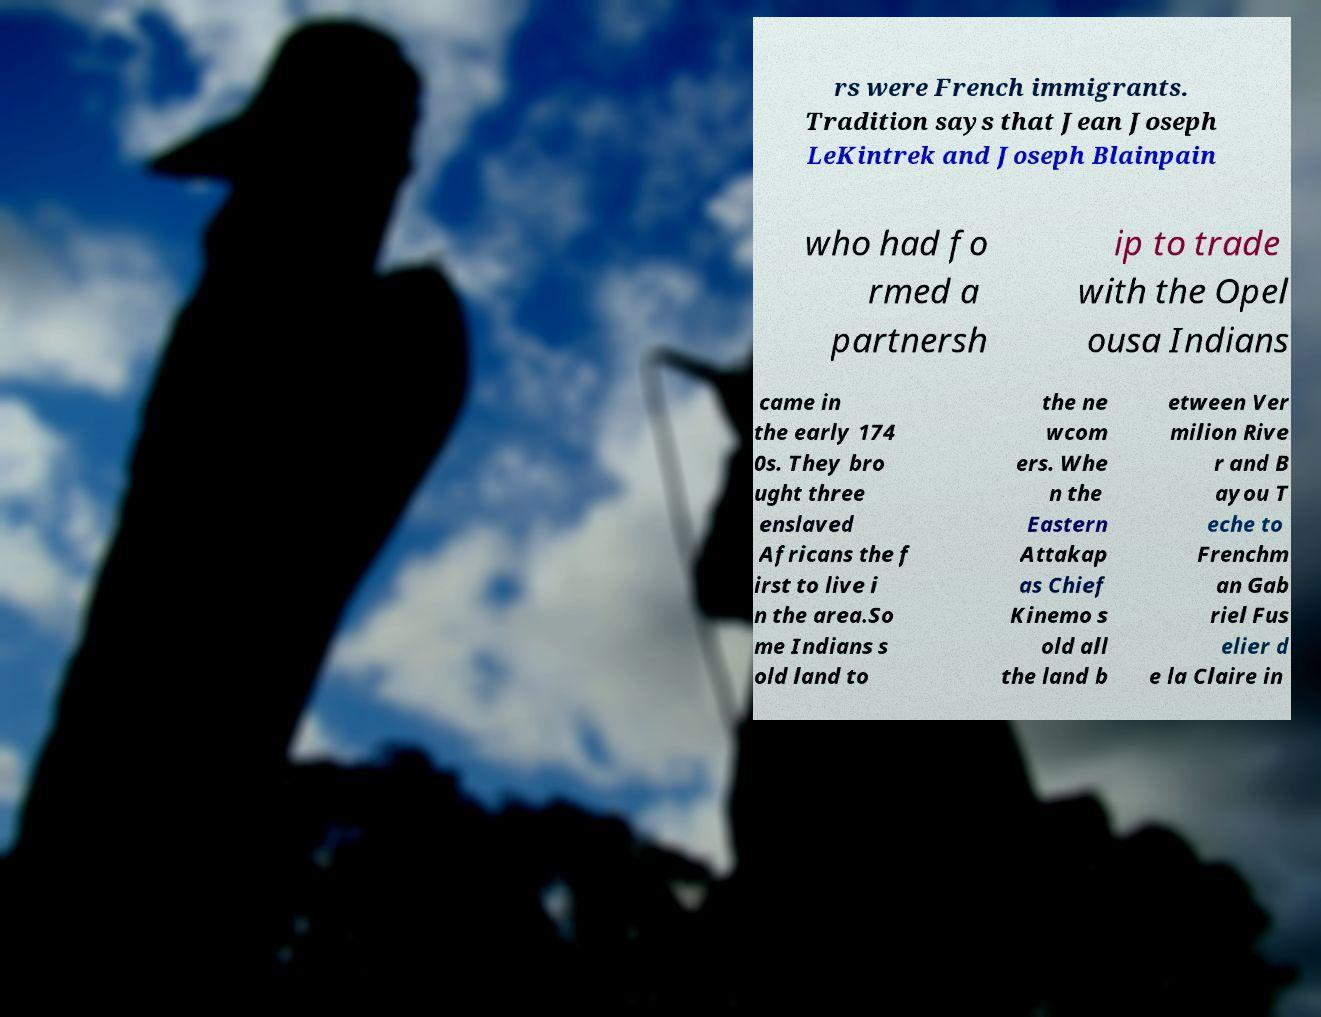Please identify and transcribe the text found in this image. rs were French immigrants. Tradition says that Jean Joseph LeKintrek and Joseph Blainpain who had fo rmed a partnersh ip to trade with the Opel ousa Indians came in the early 174 0s. They bro ught three enslaved Africans the f irst to live i n the area.So me Indians s old land to the ne wcom ers. Whe n the Eastern Attakap as Chief Kinemo s old all the land b etween Ver milion Rive r and B ayou T eche to Frenchm an Gab riel Fus elier d e la Claire in 